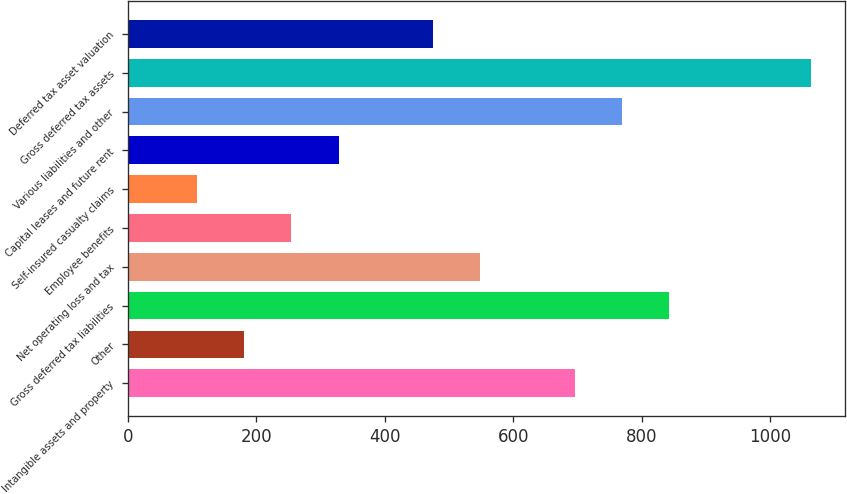Convert chart. <chart><loc_0><loc_0><loc_500><loc_500><bar_chart><fcel>Intangible assets and property<fcel>Other<fcel>Gross deferred tax liabilities<fcel>Net operating loss and tax<fcel>Employee benefits<fcel>Self-insured casualty claims<fcel>Capital leases and future rent<fcel>Various liabilities and other<fcel>Gross deferred tax assets<fcel>Deferred tax asset valuation<nl><fcel>695.5<fcel>181<fcel>842.5<fcel>548.5<fcel>254.5<fcel>107.5<fcel>328<fcel>769<fcel>1063<fcel>475<nl></chart> 